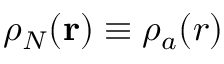<formula> <loc_0><loc_0><loc_500><loc_500>\rho _ { N } ( r ) \equiv \rho _ { a } ( r )</formula> 